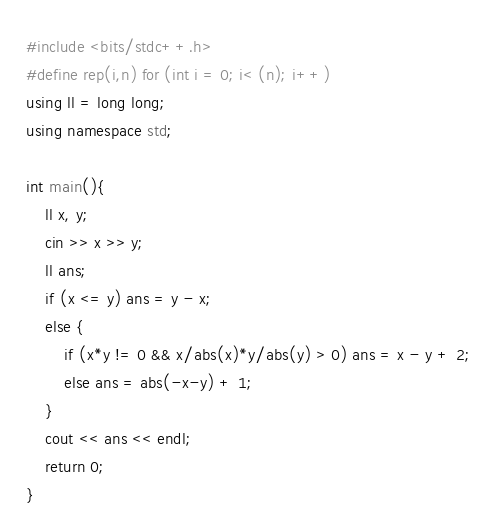<code> <loc_0><loc_0><loc_500><loc_500><_C++_>#include <bits/stdc++.h>
#define rep(i,n) for (int i = 0; i< (n); i++)
using ll = long long;
using namespace std;

int main(){
	ll x, y;
	cin >> x >> y;
	ll ans;
	if (x <= y) ans = y - x;
	else {
		if (x*y != 0 && x/abs(x)*y/abs(y) > 0) ans = x - y + 2;
		else ans = abs(-x-y) + 1;
	}
	cout << ans << endl;
	return 0;
}

</code> 